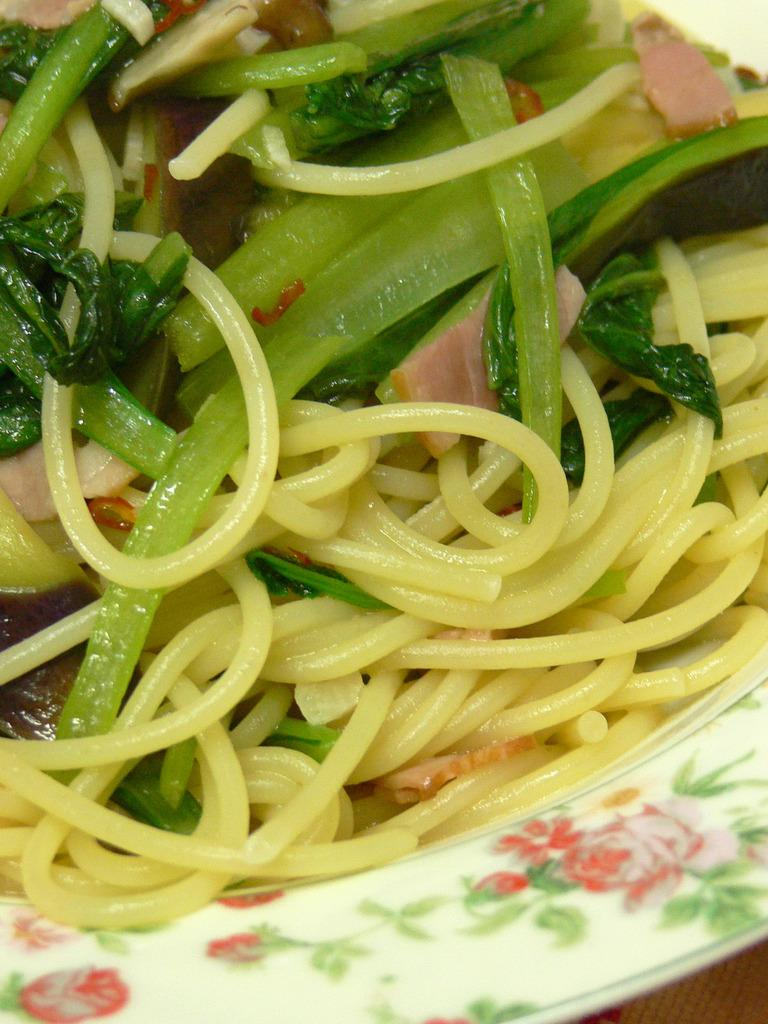What is the main subject of the image? The main subject of the image is a food item on a plate. Can you describe the food item in more detail? Unfortunately, the specific food item cannot be identified from the given facts. Is there any additional context or objects present in the image? No additional context or objects are mentioned in the provided facts. What type of teaching method is being demonstrated by the snail in the image? There is no snail present in the image, and therefore no teaching method can be observed. 